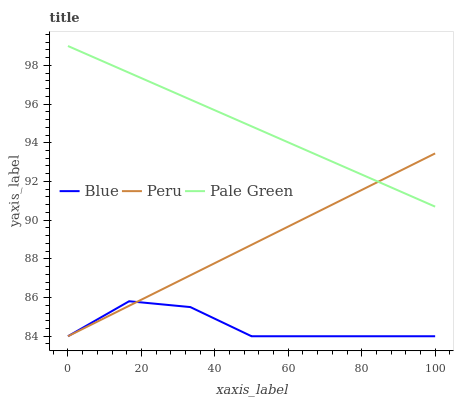Does Blue have the minimum area under the curve?
Answer yes or no. Yes. Does Pale Green have the maximum area under the curve?
Answer yes or no. Yes. Does Peru have the minimum area under the curve?
Answer yes or no. No. Does Peru have the maximum area under the curve?
Answer yes or no. No. Is Pale Green the smoothest?
Answer yes or no. Yes. Is Blue the roughest?
Answer yes or no. Yes. Is Peru the smoothest?
Answer yes or no. No. Is Peru the roughest?
Answer yes or no. No. Does Blue have the lowest value?
Answer yes or no. Yes. Does Pale Green have the lowest value?
Answer yes or no. No. Does Pale Green have the highest value?
Answer yes or no. Yes. Does Peru have the highest value?
Answer yes or no. No. Is Blue less than Pale Green?
Answer yes or no. Yes. Is Pale Green greater than Blue?
Answer yes or no. Yes. Does Peru intersect Blue?
Answer yes or no. Yes. Is Peru less than Blue?
Answer yes or no. No. Is Peru greater than Blue?
Answer yes or no. No. Does Blue intersect Pale Green?
Answer yes or no. No. 